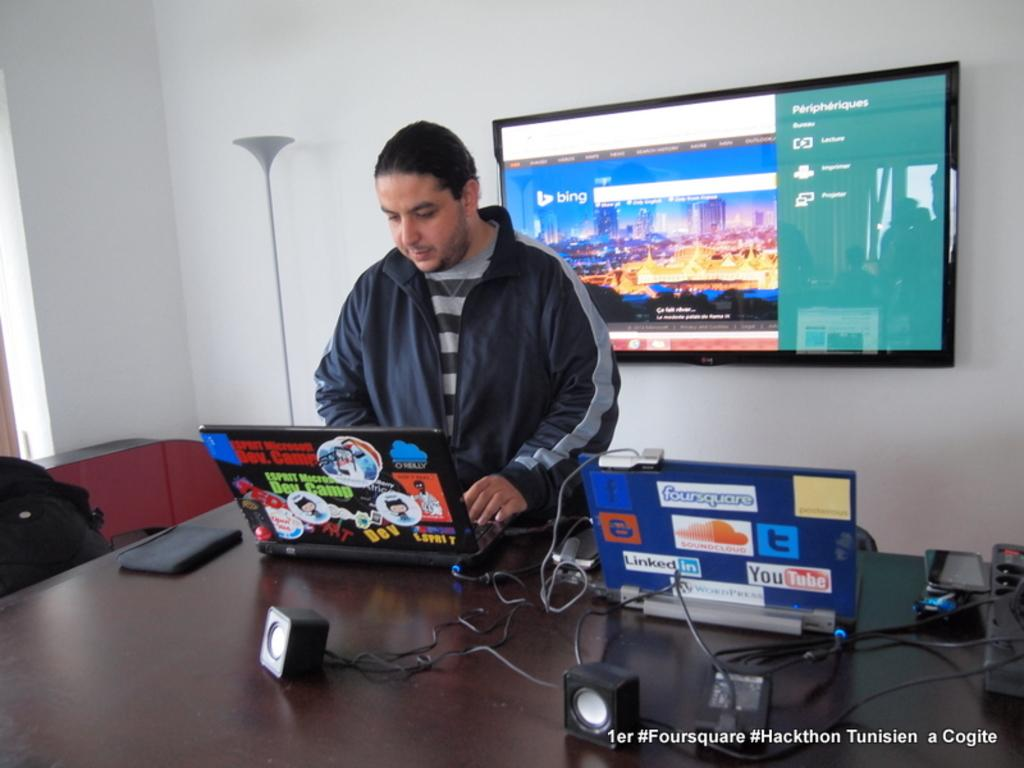<image>
Write a terse but informative summary of the picture. A man stands in front of two laptops covered in stickers such as youtube, twitter, foursquare and more, possibly mirroring his screen on the tv behind him. 